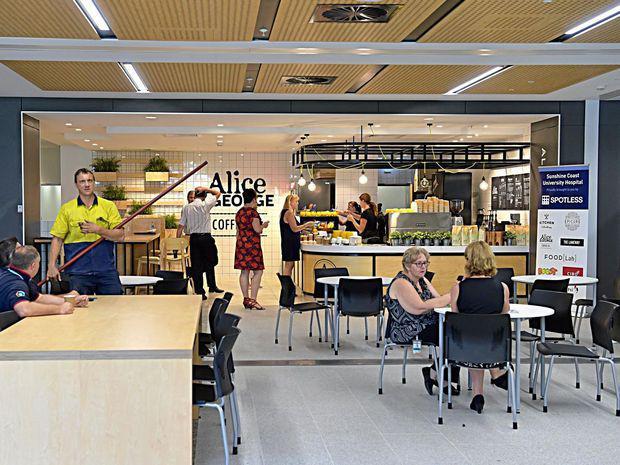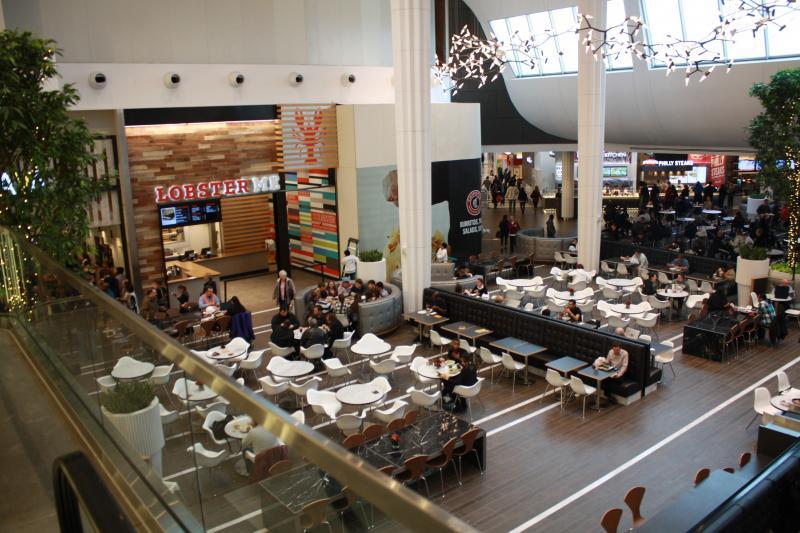The first image is the image on the left, the second image is the image on the right. Examine the images to the left and right. Is the description "One image shows a restaurant with a black band running around the top, with white lettering on it, and at least one rectangular upright stand under it." accurate? Answer yes or no. No. The first image is the image on the left, the second image is the image on the right. For the images shown, is this caption "There are people sitting in chairs in the left image." true? Answer yes or no. Yes. 